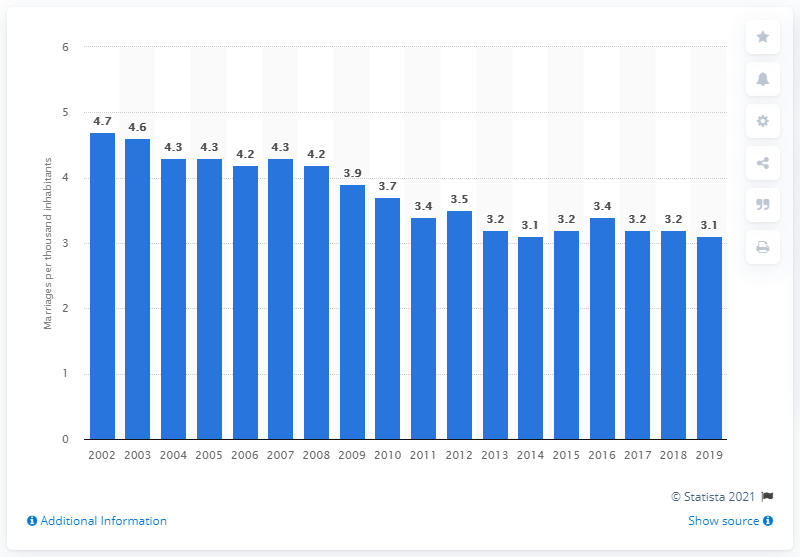Identify some key points in this picture. In 2019, Italy registered a rate of 3.1 marriages per thousand people. 